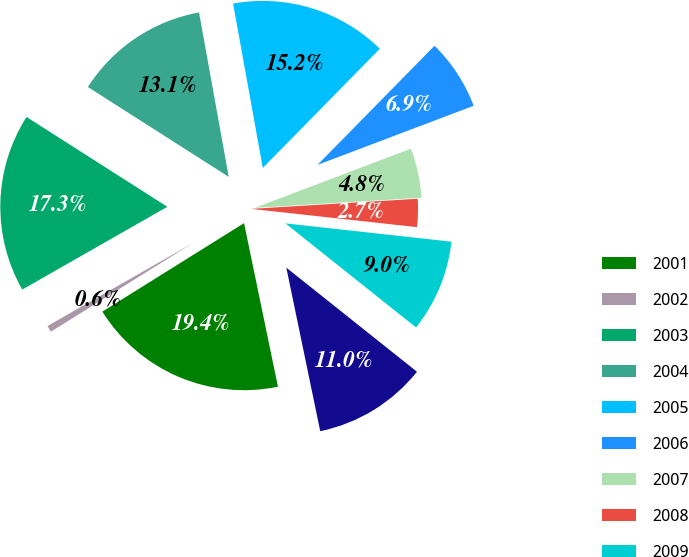Convert chart to OTSL. <chart><loc_0><loc_0><loc_500><loc_500><pie_chart><fcel>2001<fcel>2002<fcel>2003<fcel>2004<fcel>2005<fcel>2006<fcel>2007<fcel>2008<fcel>2009<fcel>Thereafter<nl><fcel>19.37%<fcel>0.63%<fcel>17.29%<fcel>13.12%<fcel>15.2%<fcel>6.88%<fcel>4.8%<fcel>2.71%<fcel>8.96%<fcel>11.04%<nl></chart> 